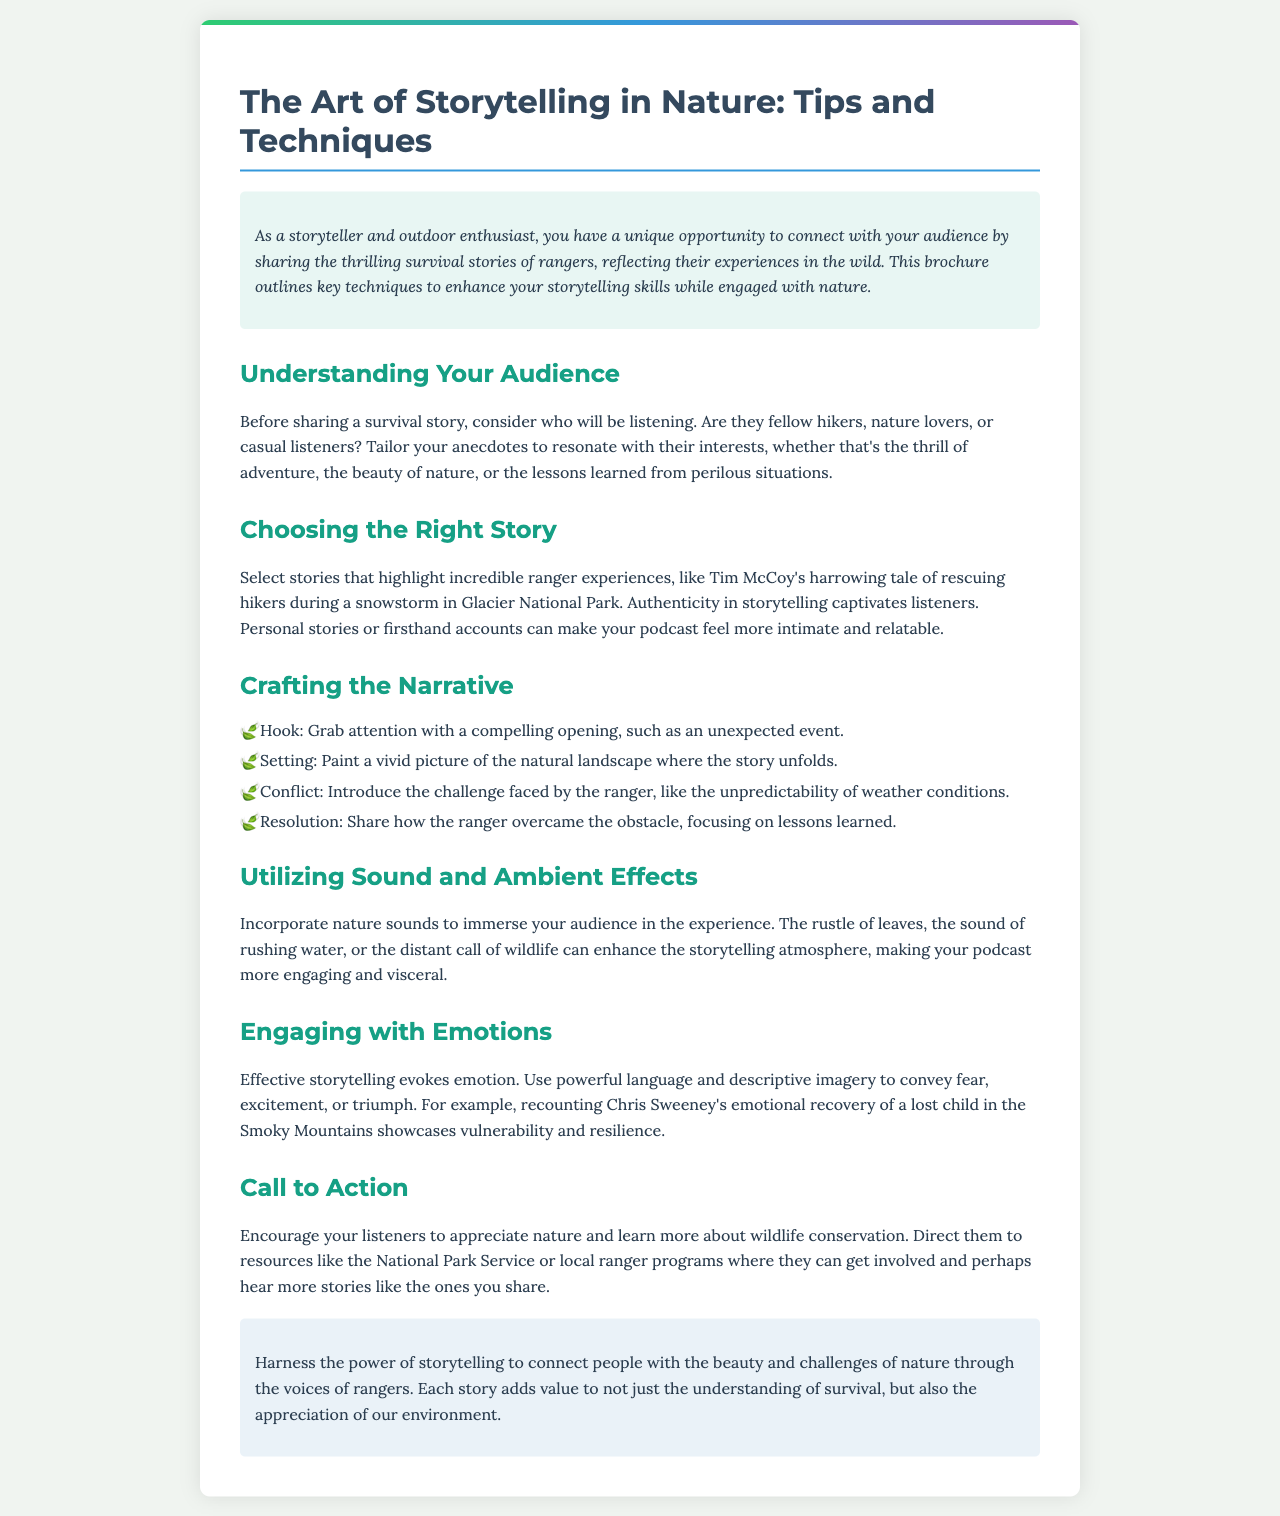What is the title of the brochure? The title of the brochure is clearly stated at the beginning.
Answer: The Art of Storytelling in Nature: Tips and Techniques Who is the target audience mentioned in the introduction? The introduction specifies that the audience includes outdoor enthusiasts and storytellers who connect with rangers' experiences.
Answer: Outdoor enthusiasts What is one example of a ranger's survival story included in the document? A specific story is highlighted to illustrate the technique of storytelling.
Answer: Tim McCoy's harrowing tale What are the four parts listed under "Crafting the Narrative"? These parts contain key elements to include in storytelling, making them essential for a compelling narrative.
Answer: Hook, Setting, Conflict, Resolution What is suggested to enhance the storytelling atmosphere? The document recommends an auditory element to create a more immersive experience for listeners.
Answer: Nature sounds What emotional response is encouraged through storytelling? The document emphasizes evoking feelings, which adds depth to the narration.
Answer: Emotion What action does the brochure suggest listeners take after hearing the stories? The brochure concludes with a call to inspire listener participation in wildlife awareness efforts.
Answer: Appreciate nature What format is the brochure presented in? The structure and presentation style of the document indicate it serves as a guide or informational pamphlet.
Answer: Brochure 